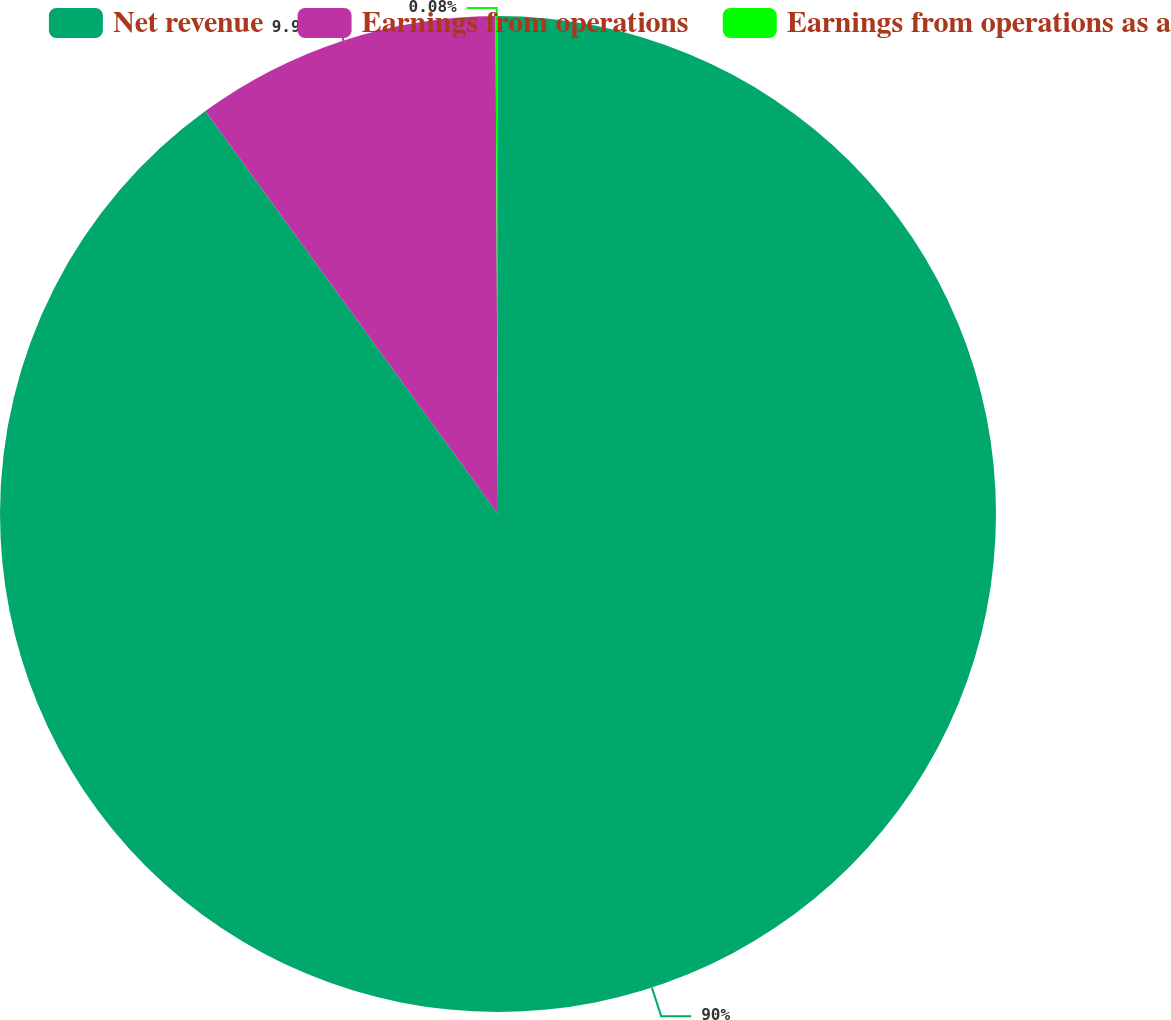Convert chart to OTSL. <chart><loc_0><loc_0><loc_500><loc_500><pie_chart><fcel>Net revenue<fcel>Earnings from operations<fcel>Earnings from operations as a<nl><fcel>90.0%<fcel>9.92%<fcel>0.08%<nl></chart> 